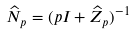Convert formula to latex. <formula><loc_0><loc_0><loc_500><loc_500>\widehat { N } _ { p } = ( p I + \widehat { Z } _ { p } ) ^ { - 1 }</formula> 